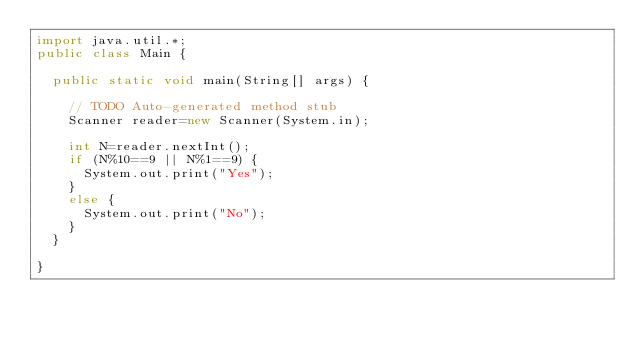<code> <loc_0><loc_0><loc_500><loc_500><_Java_>import java.util.*;
public class Main {

	public static void main(String[] args) {
		
		// TODO Auto-generated method stub
		Scanner reader=new Scanner(System.in);

		int N=reader.nextInt();
		if (N%10==9 || N%1==9) {
			System.out.print("Yes");
		}
		else {
			System.out.print("No");
		}
 	}

}
</code> 